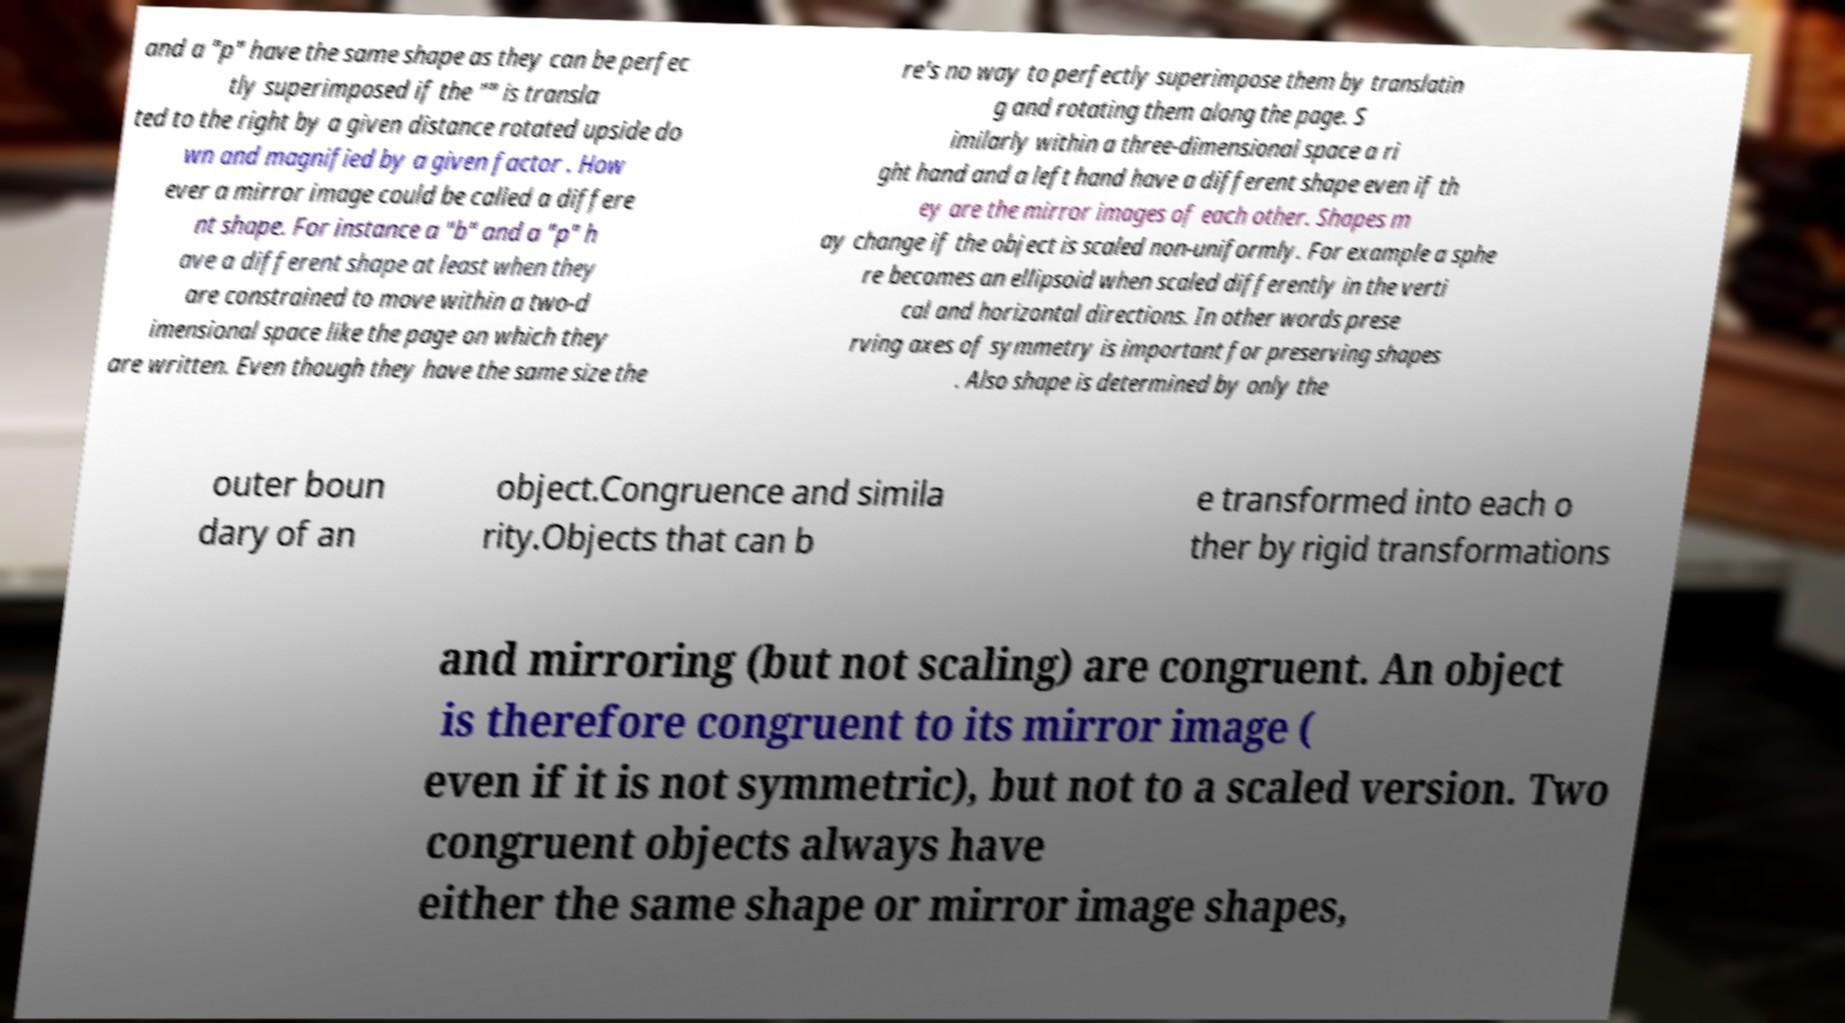Can you read and provide the text displayed in the image?This photo seems to have some interesting text. Can you extract and type it out for me? and a "p" have the same shape as they can be perfec tly superimposed if the "" is transla ted to the right by a given distance rotated upside do wn and magnified by a given factor . How ever a mirror image could be called a differe nt shape. For instance a "b" and a "p" h ave a different shape at least when they are constrained to move within a two-d imensional space like the page on which they are written. Even though they have the same size the re's no way to perfectly superimpose them by translatin g and rotating them along the page. S imilarly within a three-dimensional space a ri ght hand and a left hand have a different shape even if th ey are the mirror images of each other. Shapes m ay change if the object is scaled non-uniformly. For example a sphe re becomes an ellipsoid when scaled differently in the verti cal and horizontal directions. In other words prese rving axes of symmetry is important for preserving shapes . Also shape is determined by only the outer boun dary of an object.Congruence and simila rity.Objects that can b e transformed into each o ther by rigid transformations and mirroring (but not scaling) are congruent. An object is therefore congruent to its mirror image ( even if it is not symmetric), but not to a scaled version. Two congruent objects always have either the same shape or mirror image shapes, 